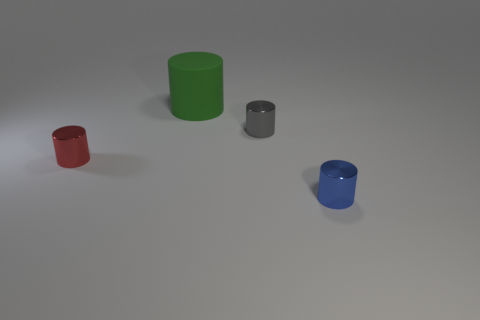Is the number of red objects that are left of the blue shiny thing greater than the number of tiny blue metallic cylinders behind the gray metal object?
Make the answer very short. Yes. What is the small gray cylinder made of?
Your answer should be compact. Metal. What shape is the tiny object that is on the left side of the small metallic thing that is behind the thing left of the green object?
Your response must be concise. Cylinder. How many other things are there of the same material as the tiny blue cylinder?
Your response must be concise. 2. Is the material of the blue cylinder to the right of the tiny red metallic object the same as the thing that is to the left of the green cylinder?
Provide a succinct answer. Yes. How many things are behind the blue thing and in front of the large cylinder?
Provide a short and direct response. 2. Are there any small blue objects of the same shape as the green matte object?
Offer a very short reply. Yes. What shape is the blue thing that is the same size as the gray metal cylinder?
Offer a terse response. Cylinder. Is the number of large green rubber cylinders that are behind the red shiny object the same as the number of blue metal cylinders behind the blue thing?
Give a very brief answer. No. There is a matte thing that is behind the shiny cylinder left of the gray metallic cylinder; what is its size?
Ensure brevity in your answer.  Large. 